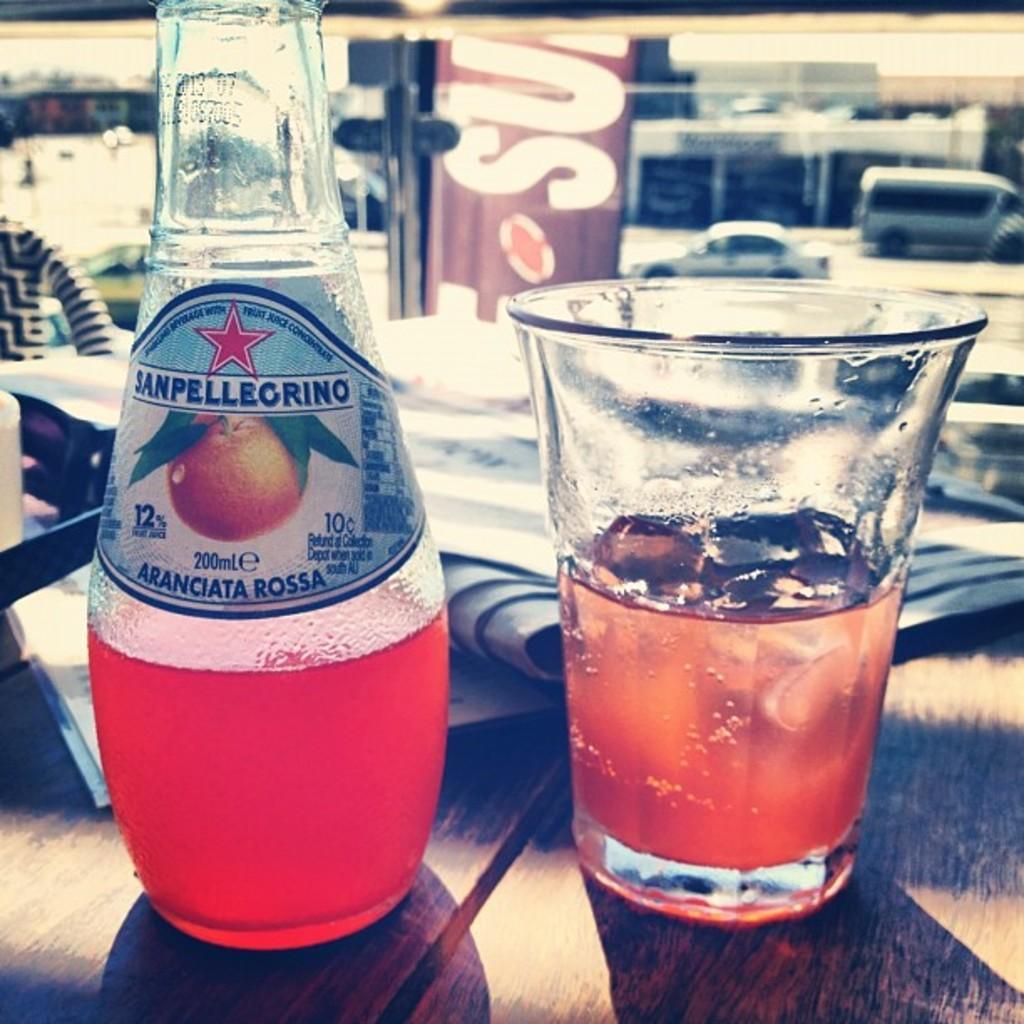In one or two sentences, can you explain what this image depicts? In this picture I can observe a bottle and glass placed on the table. I can observe some papers on the table. In the background I can observe some vehicles moving on the road. 